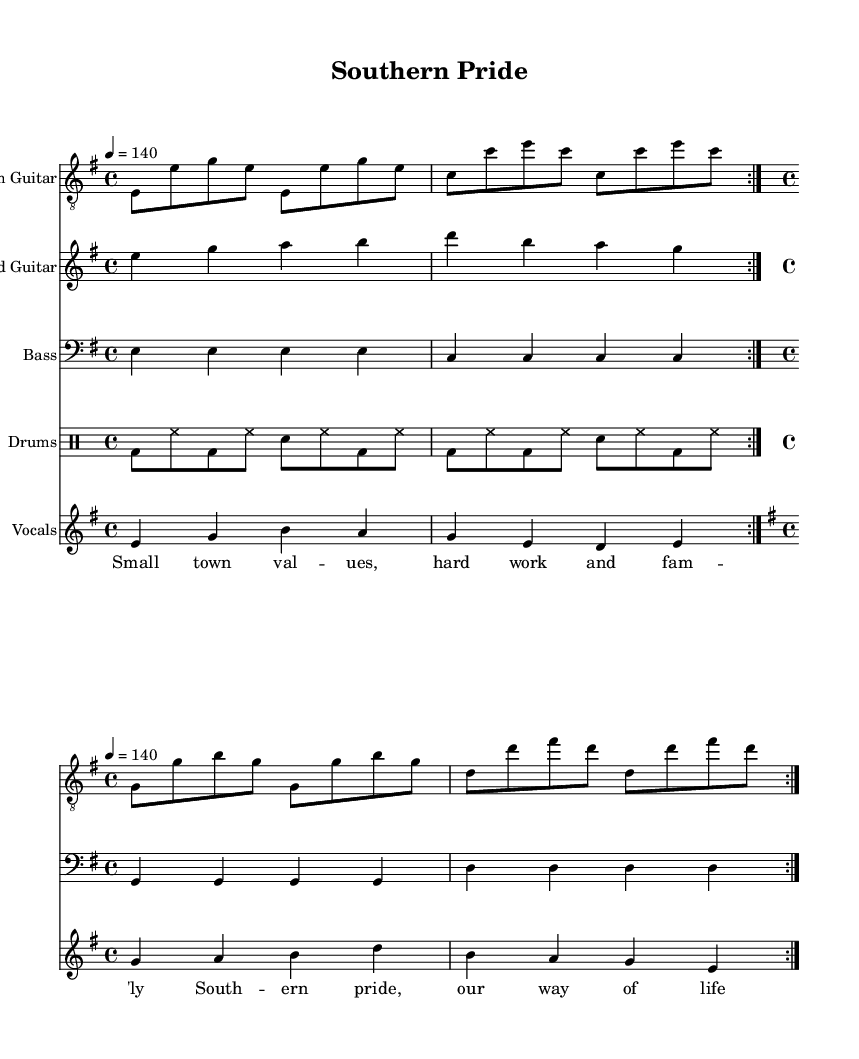What is the key signature of this music? The key signature is E minor, which has one sharp (F#) and is indicated at the beginning of the staff.
Answer: E minor What is the time signature of this music? The time signature is 4/4, which means there are four beats per measure, and it's marked at the beginning of the score.
Answer: 4/4 What is the tempo marking for this piece? The tempo marking indicates a speed of 140 beats per minute, shown as "4 = 140" above the global settings.
Answer: 140 How many times is the main rhythmic section repeated? The main rhythmic section is repeated twice, as indicated by "volta 2" in the rhythm guitar part.
Answer: Twice What are the first two words of the verse lyrics? The verse lyrics begin with "Small town," as shown in the lyrics section below the vocal staff.
Answer: Small town What is the dynamic level suggested by the use of electric guitar in this piece? The use of electric guitar suggests a strong dynamic level typical of metal music, which often conveys power and intensity. The rhythmic and lead guitar patterns contribute to this heavy sound.
Answer: Strong What main theme is expressed in the chorus lyrics? The chorus lyrics reflect the theme of Southern pride and a traditional lifestyle, focusing on values and identity. This aligns with the values expressed in the song overall.
Answer: Southern pride 